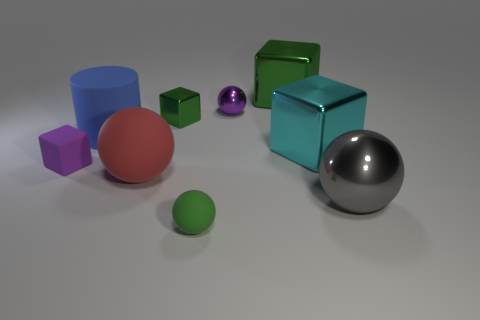Is the color of the tiny matte cube the same as the tiny sphere that is behind the large blue matte thing?
Keep it short and to the point. Yes. There is a small thing that is the same color as the tiny rubber block; what is its material?
Your answer should be compact. Metal. There is another matte object that is the same shape as the red matte thing; what size is it?
Your response must be concise. Small. Is the cyan thing the same shape as the blue thing?
Provide a short and direct response. No. Is the number of gray metallic things that are in front of the gray shiny object less than the number of red spheres that are to the left of the purple metal thing?
Your answer should be compact. Yes. What number of cubes are behind the rubber cube?
Keep it short and to the point. 3. Does the large rubber thing that is to the right of the blue matte cylinder have the same shape as the green thing that is in front of the gray thing?
Provide a short and direct response. Yes. How many other things are the same color as the cylinder?
Your answer should be very brief. 0. There is a tiny purple thing that is left of the rubber object that is behind the small matte thing that is left of the blue thing; what is it made of?
Offer a terse response. Rubber. What is the material of the small sphere in front of the small rubber thing that is left of the green rubber sphere?
Ensure brevity in your answer.  Rubber. 